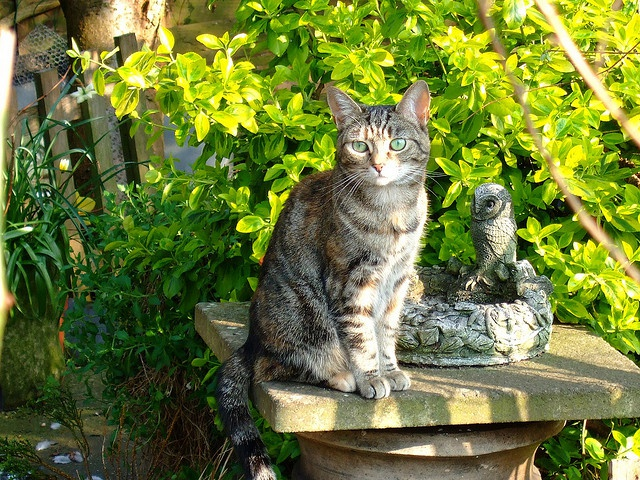Describe the objects in this image and their specific colors. I can see cat in darkgreen, black, gray, ivory, and darkgray tones and bird in darkgreen, black, gray, beige, and darkgray tones in this image. 